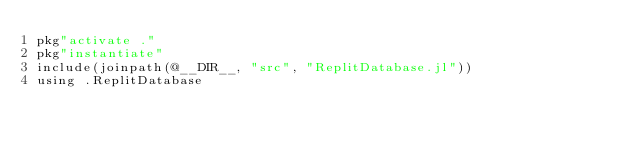<code> <loc_0><loc_0><loc_500><loc_500><_Julia_>pkg"activate ."
pkg"instantiate"
include(joinpath(@__DIR__, "src", "ReplitDatabase.jl"))
using .ReplitDatabase
</code> 